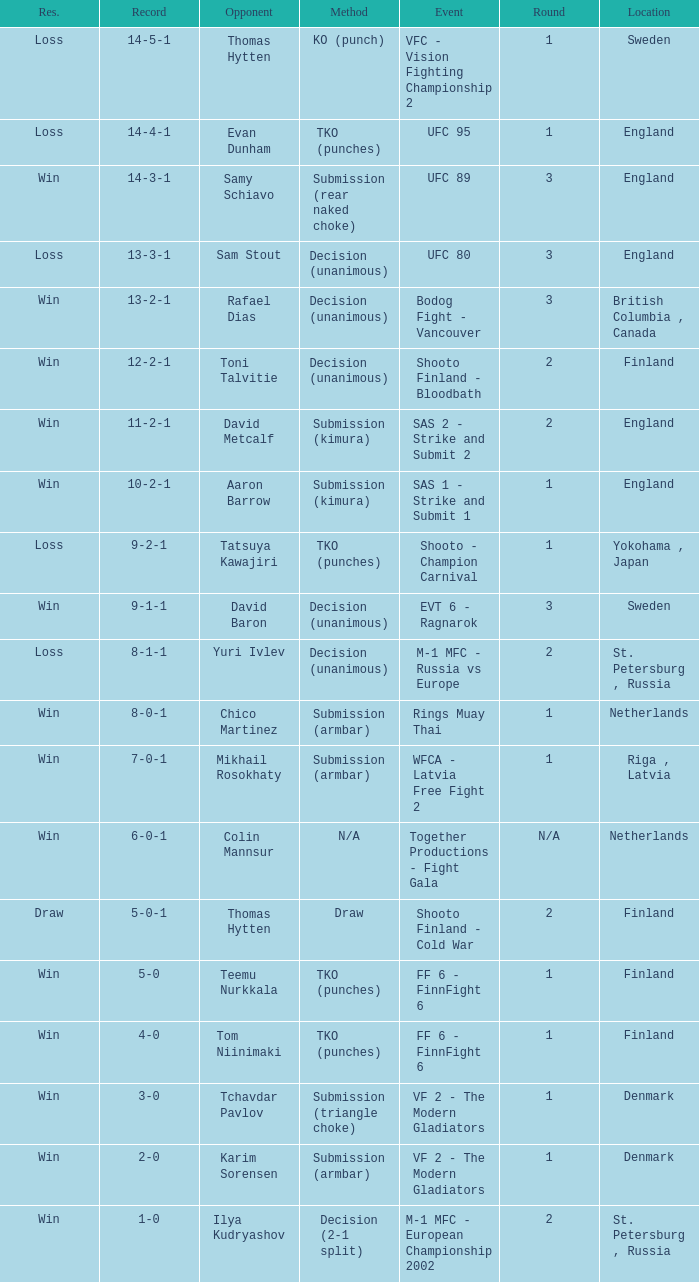What is the circular stage in finland with a drawing for technique? 2.0. 